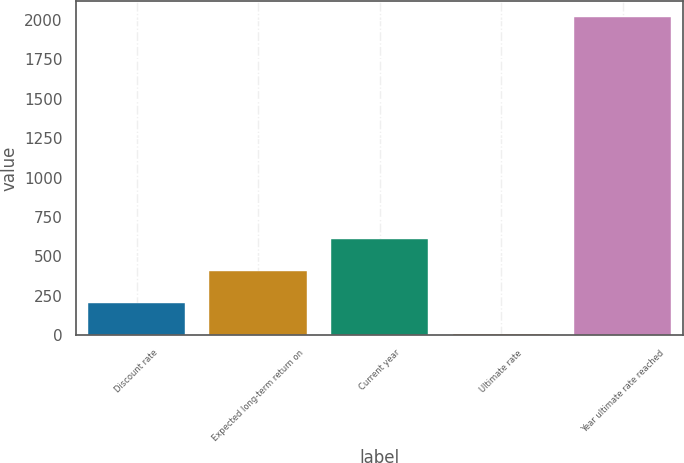<chart> <loc_0><loc_0><loc_500><loc_500><bar_chart><fcel>Discount rate<fcel>Expected long-term return on<fcel>Current year<fcel>Ultimate rate<fcel>Year ultimate rate reached<nl><fcel>206.55<fcel>407.6<fcel>608.65<fcel>5.5<fcel>2016<nl></chart> 